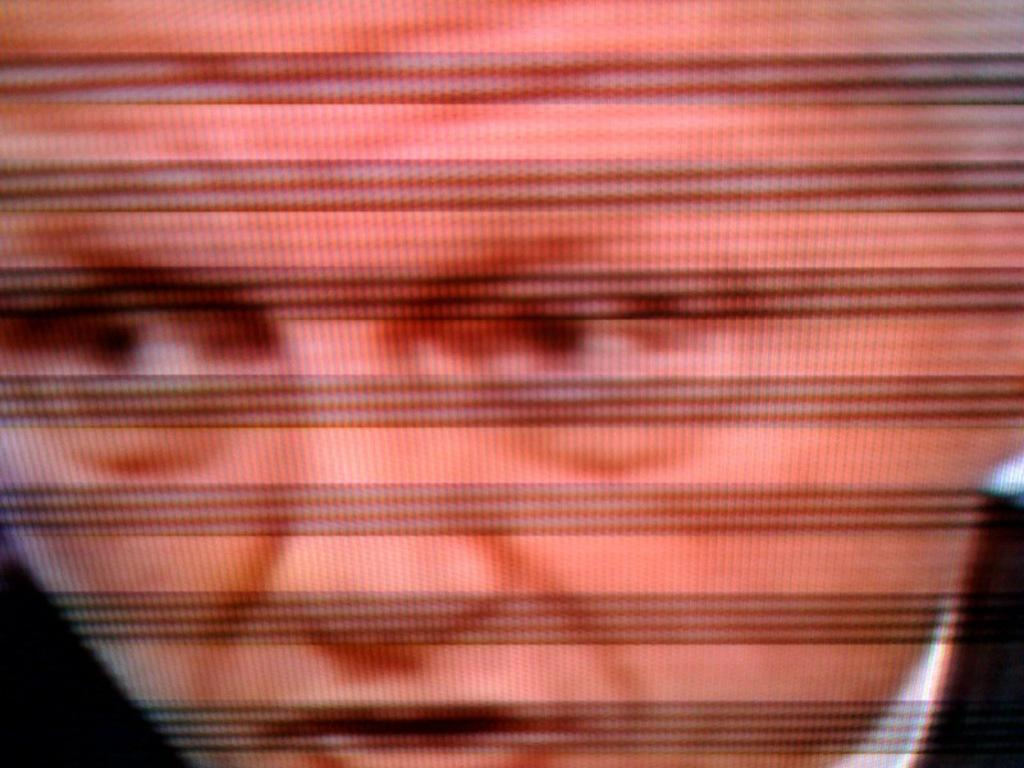What is the main subject visible in the image? There is a person visible on the screen in the image. How much money is the person holding in the image? There is no information about money or any objects the person might be holding in the image. 